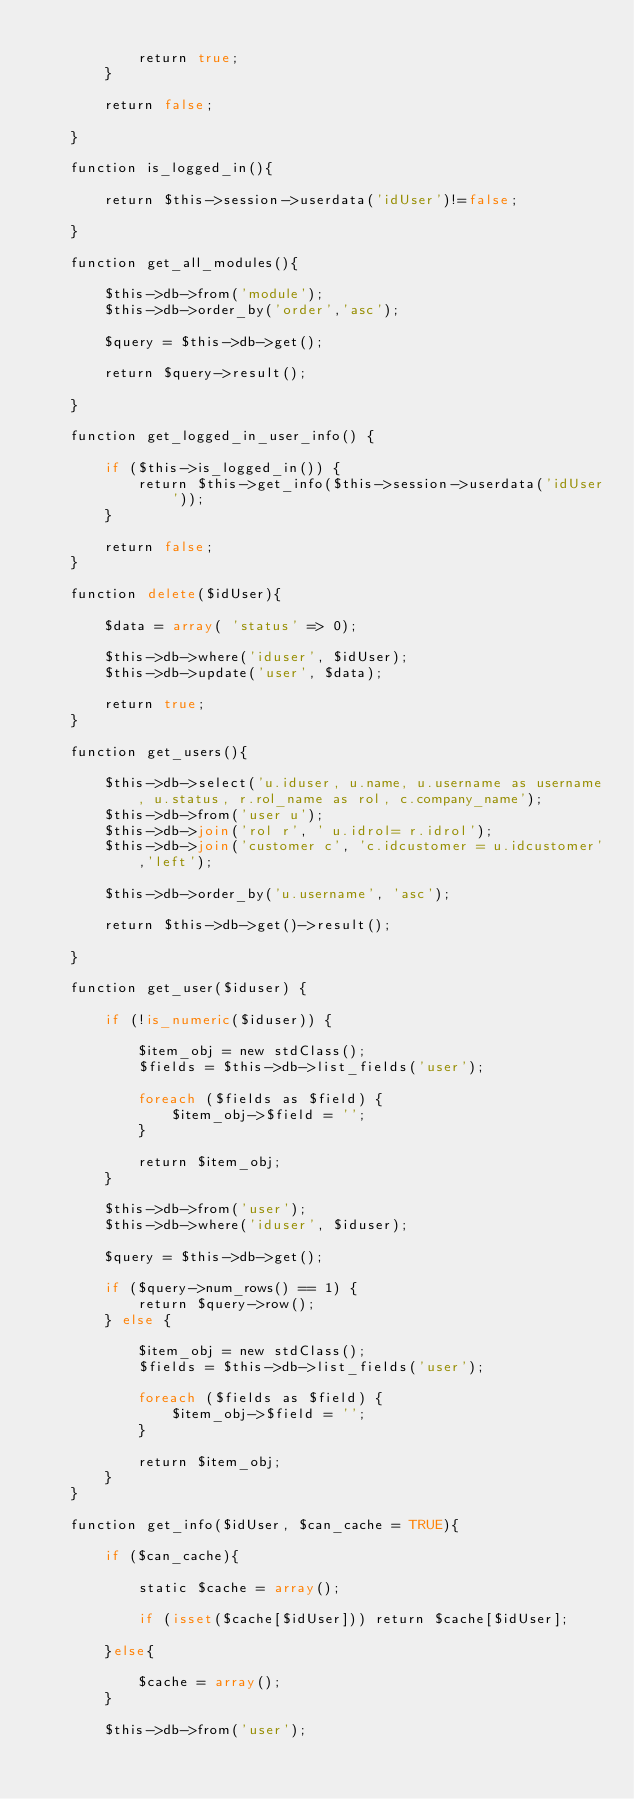Convert code to text. <code><loc_0><loc_0><loc_500><loc_500><_PHP_>            
            return true;
        }
        
        return false;
        
    }
    
    function is_logged_in(){      
        
        return $this->session->userdata('idUser')!=false;
        
    }
    
    function get_all_modules(){
        
        $this->db->from('module');
        $this->db->order_by('order','asc');
        
        $query = $this->db->get();
        
        return $query->result();
        
    }
    
    function get_logged_in_user_info() {

        if ($this->is_logged_in()) {
            return $this->get_info($this->session->userdata('idUser'));
        }

        return false;
    }
    
    function delete($idUser){
        
        $data = array( 'status' => 0);

        $this->db->where('iduser', $idUser);
        $this->db->update('user', $data); 

        return true;
    }
    
    function get_users(){
        
        $this->db->select('u.iduser, u.name, u.username as username, u.status, r.rol_name as rol, c.company_name');
        $this->db->from('user u');
        $this->db->join('rol r', ' u.idrol= r.idrol');
        $this->db->join('customer c', 'c.idcustomer = u.idcustomer','left');
        
        $this->db->order_by('u.username', 'asc');
        
        return $this->db->get()->result();
        
    }
    
    function get_user($iduser) {

        if (!is_numeric($iduser)) {

            $item_obj = new stdClass();
            $fields = $this->db->list_fields('user');

            foreach ($fields as $field) {
                $item_obj->$field = '';
            }

            return $item_obj;
        }

        $this->db->from('user');
        $this->db->where('iduser', $iduser);

        $query = $this->db->get();

        if ($query->num_rows() == 1) {
            return $query->row();
        } else {

            $item_obj = new stdClass();
            $fields = $this->db->list_fields('user');
            
            foreach ($fields as $field) {
                $item_obj->$field = '';
            }

            return $item_obj;
        }
    }
    
    function get_info($idUser, $can_cache = TRUE){
        
        if ($can_cache){

            static $cache = array();

            if (isset($cache[$idUser])) return $cache[$idUser];

        }else{

            $cache = array();
        }

        $this->db->from('user');</code> 